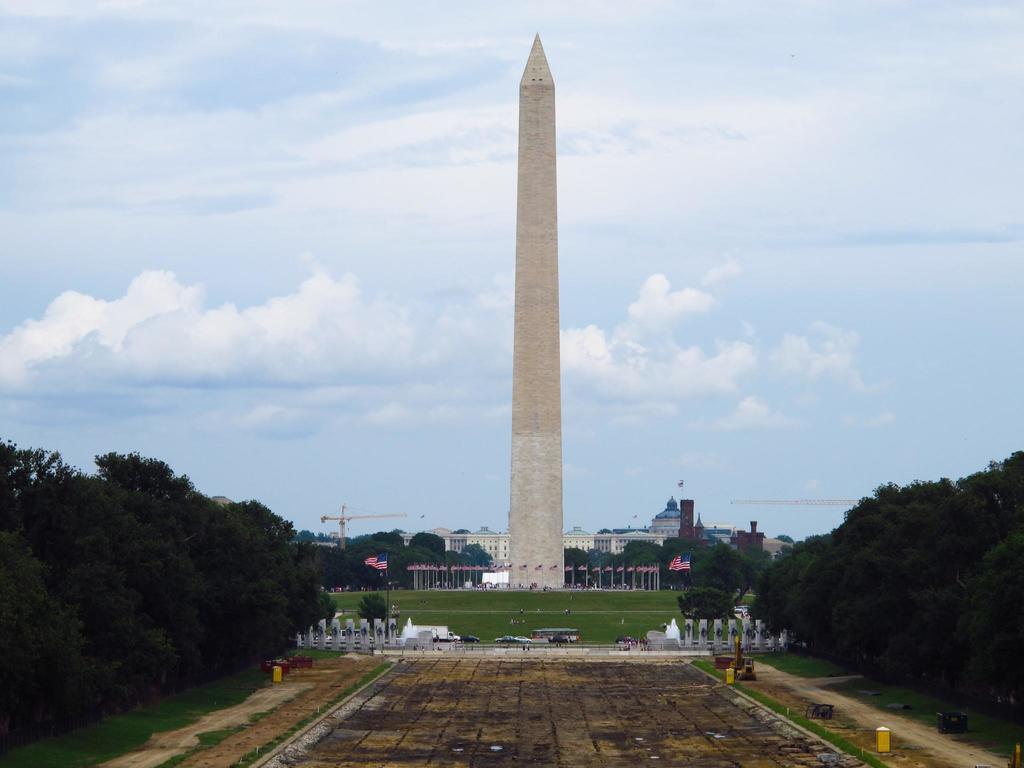In one or two sentences, can you explain what this image depicts? In this image we can see the tower, buildings, flags, vehicles and also the trees. We can also see the crane, path, concrete pillars, grass and also the sky with the clouds in the background. 